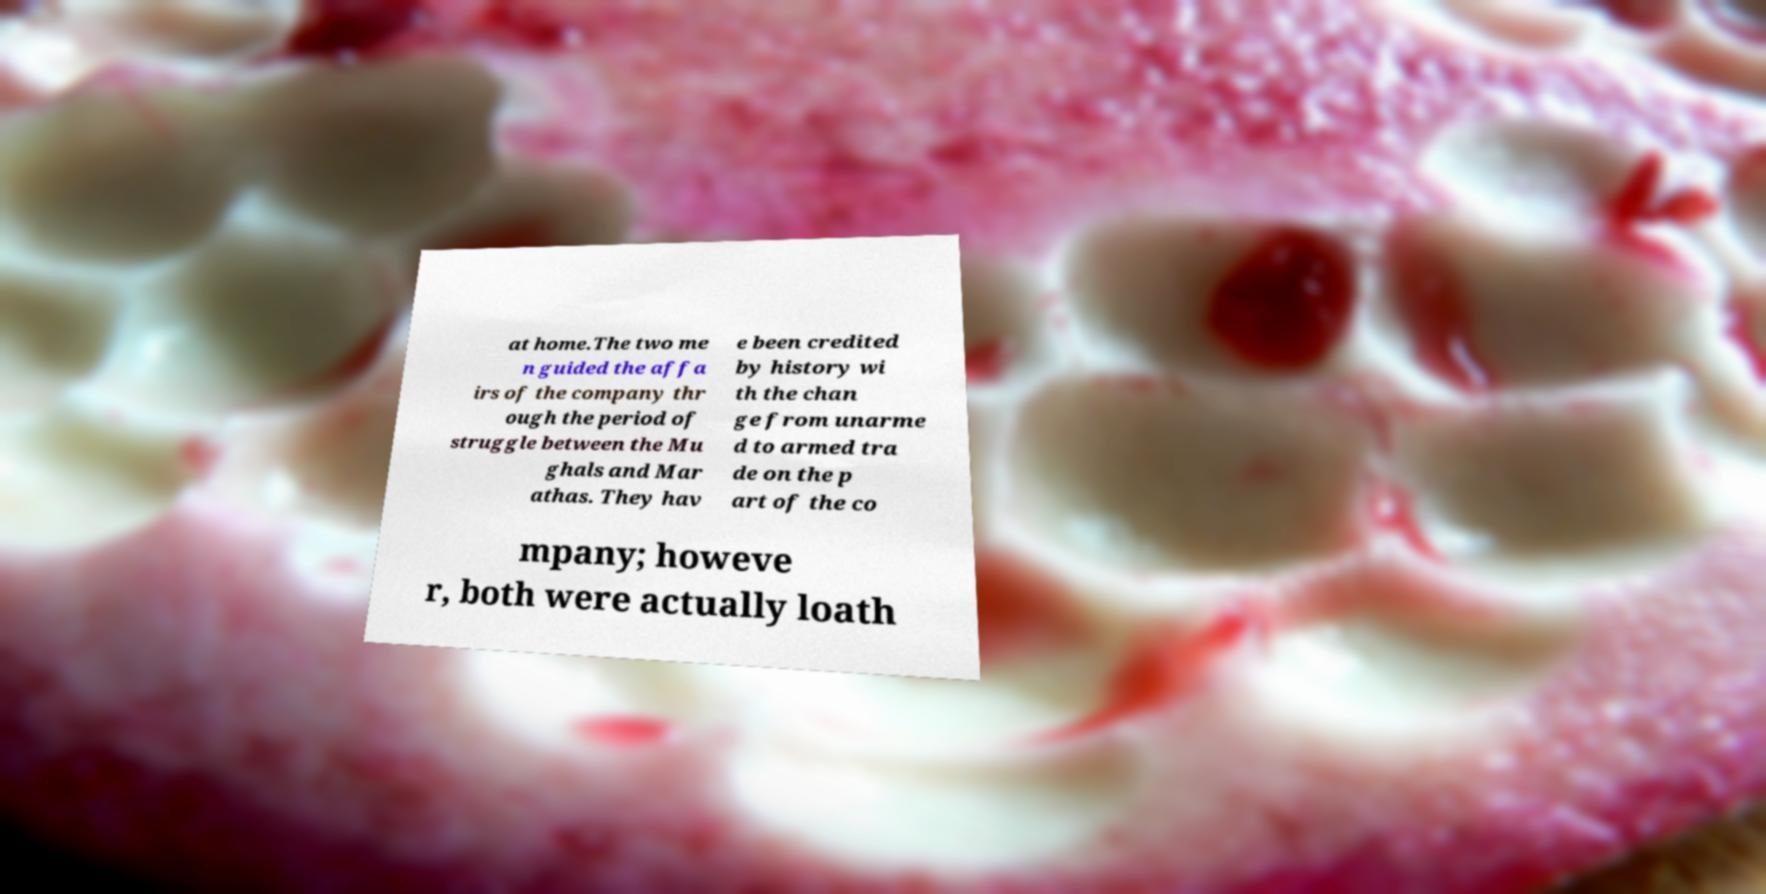What messages or text are displayed in this image? I need them in a readable, typed format. at home.The two me n guided the affa irs of the company thr ough the period of struggle between the Mu ghals and Mar athas. They hav e been credited by history wi th the chan ge from unarme d to armed tra de on the p art of the co mpany; howeve r, both were actually loath 